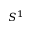<formula> <loc_0><loc_0><loc_500><loc_500>S ^ { 1 }</formula> 